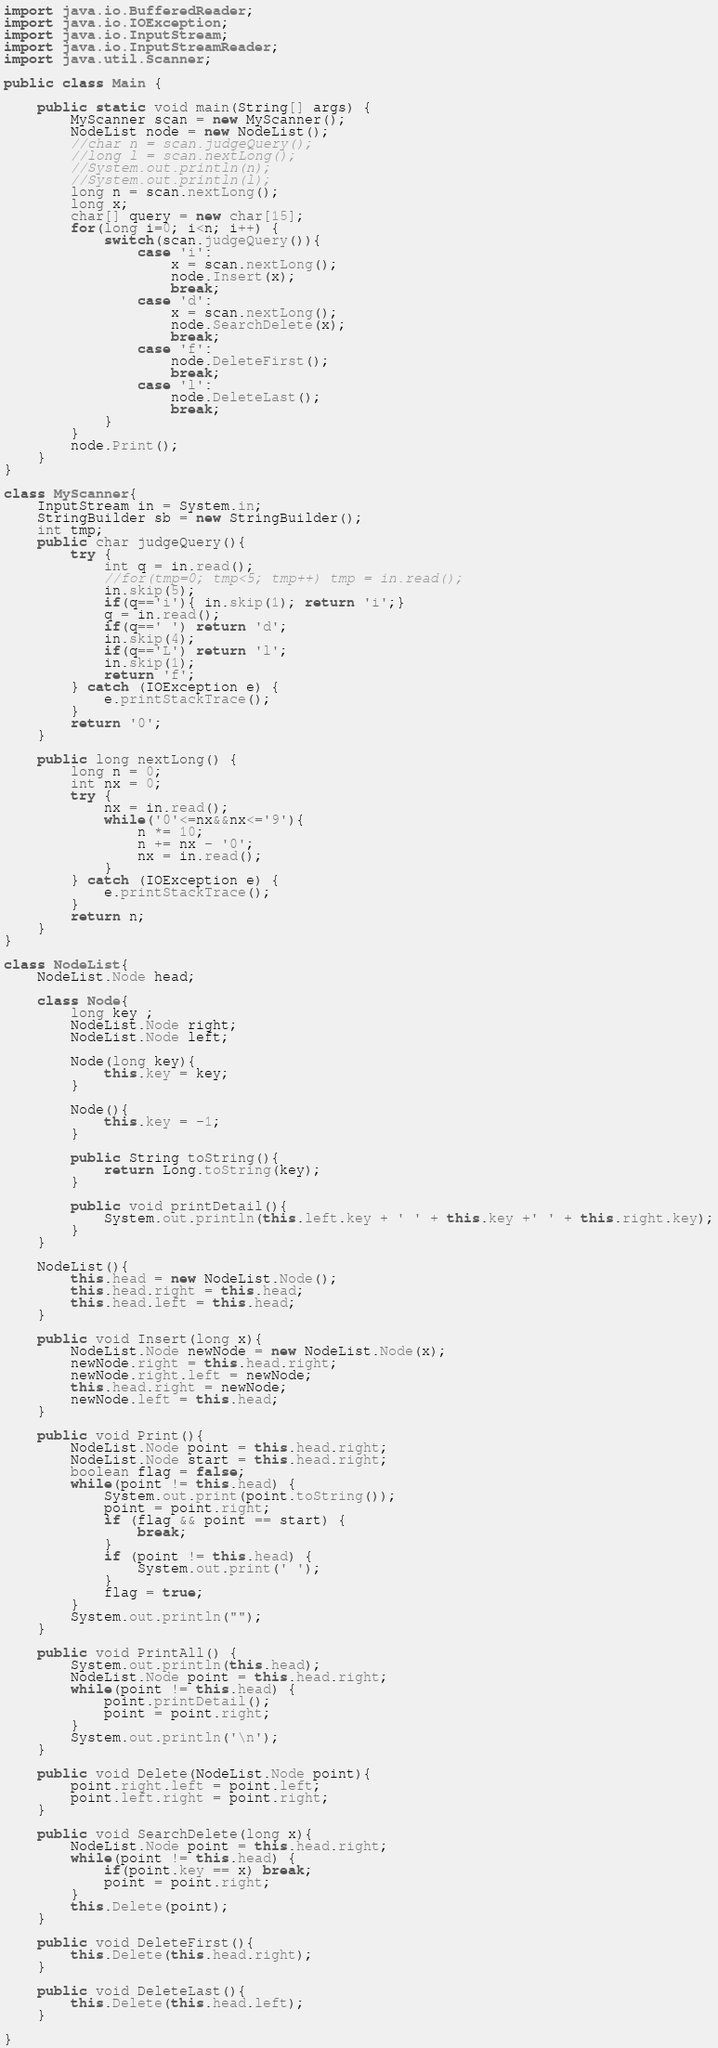<code> <loc_0><loc_0><loc_500><loc_500><_Java_>
import java.io.BufferedReader;
import java.io.IOException;
import java.io.InputStream;
import java.io.InputStreamReader;
import java.util.Scanner;

public class Main {

    public static void main(String[] args) {
        MyScanner scan = new MyScanner();
        NodeList node = new NodeList();
        //char n = scan.judgeQuery();
        //long l = scan.nextLong();
        //System.out.println(n);
        //System.out.println(l);
        long n = scan.nextLong();
        long x;
        char[] query = new char[15];
        for(long i=0; i<n; i++) {
            switch(scan.judgeQuery()){
                case 'i':
                    x = scan.nextLong();
                    node.Insert(x);
                    break;
                case 'd':
                    x = scan.nextLong();
                    node.SearchDelete(x);
                    break;
                case 'f':
                    node.DeleteFirst();
                    break;
                case 'l':
                    node.DeleteLast();
                    break;
            }
        }
        node.Print();
    }
}

class MyScanner{
    InputStream in = System.in;
    StringBuilder sb = new StringBuilder();
    int tmp;
    public char judgeQuery(){
        try {
            int q = in.read();
            //for(tmp=0; tmp<5; tmp++) tmp = in.read();
            in.skip(5);
            if(q=='i'){ in.skip(1); return 'i';}
            q = in.read();
            if(q==' ') return 'd';
            in.skip(4);
            if(q=='L') return 'l';
            in.skip(1);
            return 'f';
        } catch (IOException e) {
            e.printStackTrace();
        }
        return '0';
    }

    public long nextLong() {
        long n = 0;
        int nx = 0;
        try {
            nx = in.read();
            while('0'<=nx&&nx<='9'){
                n *= 10;
                n += nx - '0';
                nx = in.read();
            }
        } catch (IOException e) {
            e.printStackTrace();
        }
        return n;
    }
}

class NodeList{
    NodeList.Node head;

    class Node{
        long key ;
        NodeList.Node right;
        NodeList.Node left;

        Node(long key){
            this.key = key;
        }

        Node(){
            this.key = -1;
        }

        public String toString(){
            return Long.toString(key);
        }

        public void printDetail(){
            System.out.println(this.left.key + ' ' + this.key +' ' + this.right.key);
        }
    }

    NodeList(){
        this.head = new NodeList.Node();
        this.head.right = this.head;
        this.head.left = this.head;
    }

    public void Insert(long x){
        NodeList.Node newNode = new NodeList.Node(x);
        newNode.right = this.head.right;
        newNode.right.left = newNode;
        this.head.right = newNode;
        newNode.left = this.head;
    }

    public void Print(){
        NodeList.Node point = this.head.right;
        NodeList.Node start = this.head.right;
        boolean flag = false;
        while(point != this.head) {
            System.out.print(point.toString());
            point = point.right;
            if (flag && point == start) {
                break;
            }
            if (point != this.head) {
                System.out.print(' ');
            }
            flag = true;
        }
        System.out.println("");
    }

    public void PrintAll() {
        System.out.println(this.head);
        NodeList.Node point = this.head.right;
        while(point != this.head) {
            point.printDetail();
            point = point.right;
        }
        System.out.println('\n');
    }

    public void Delete(NodeList.Node point){
        point.right.left = point.left;
        point.left.right = point.right;
    }

    public void SearchDelete(long x){
        NodeList.Node point = this.head.right;
        while(point != this.head) {
            if(point.key == x) break;
            point = point.right;
        }
        this.Delete(point);
    }

    public void DeleteFirst(){
        this.Delete(this.head.right);
    }

    public void DeleteLast(){
        this.Delete(this.head.left);
    }

}

</code> 